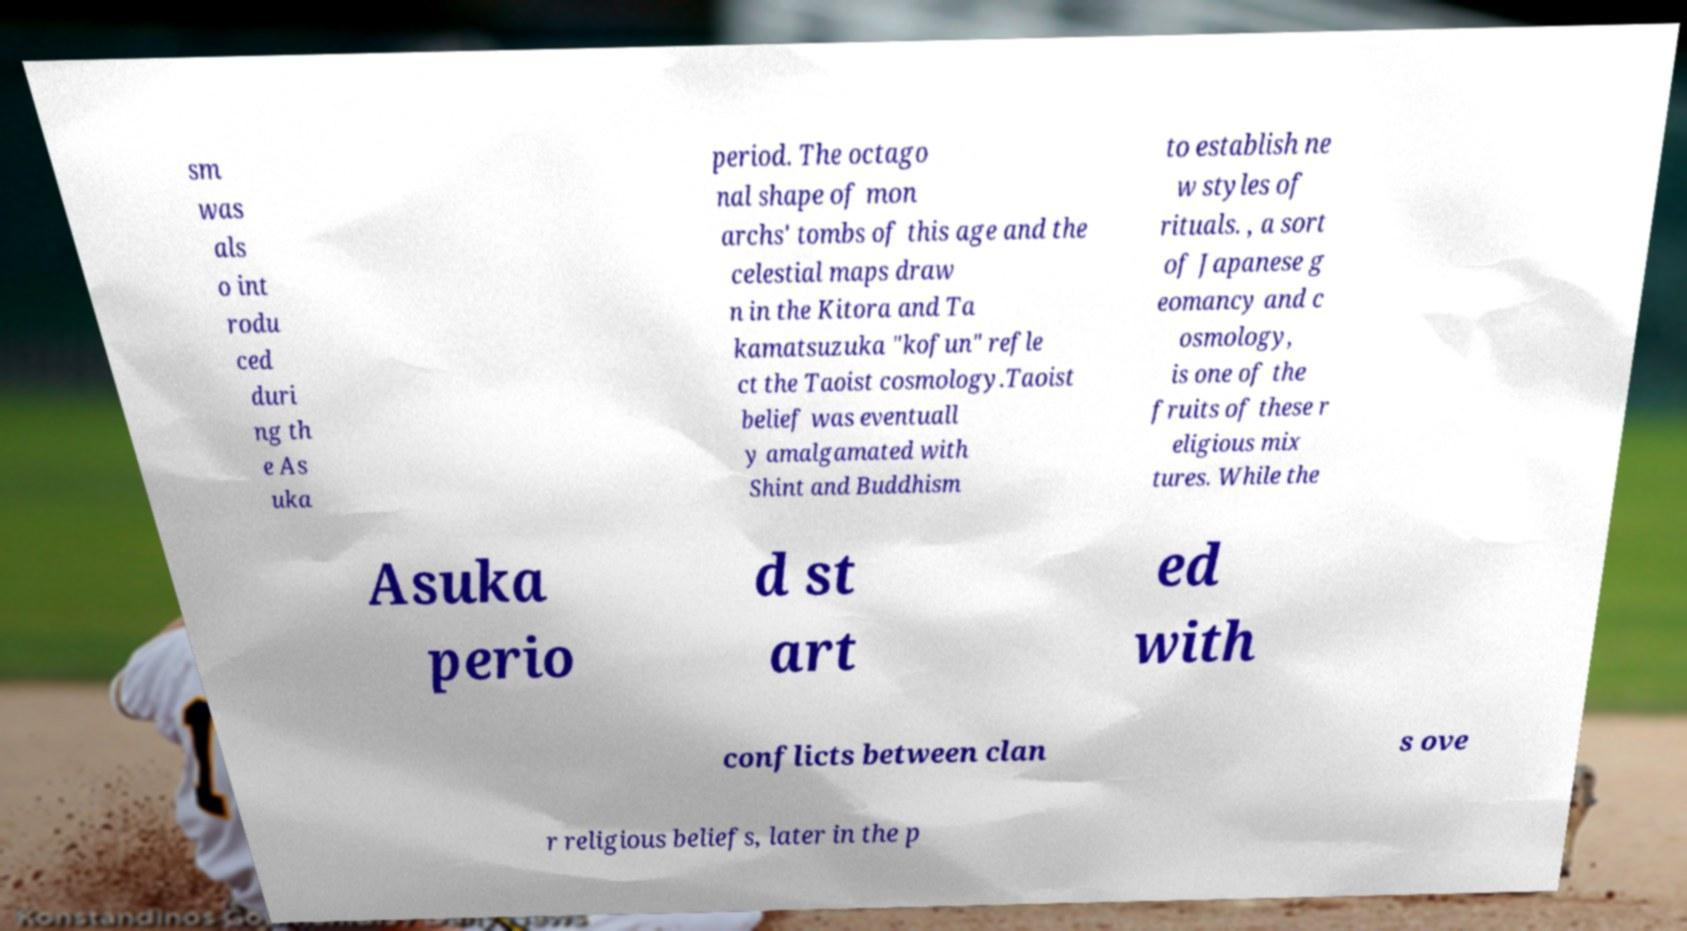Could you extract and type out the text from this image? sm was als o int rodu ced duri ng th e As uka period. The octago nal shape of mon archs' tombs of this age and the celestial maps draw n in the Kitora and Ta kamatsuzuka "kofun" refle ct the Taoist cosmology.Taoist belief was eventuall y amalgamated with Shint and Buddhism to establish ne w styles of rituals. , a sort of Japanese g eomancy and c osmology, is one of the fruits of these r eligious mix tures. While the Asuka perio d st art ed with conflicts between clan s ove r religious beliefs, later in the p 